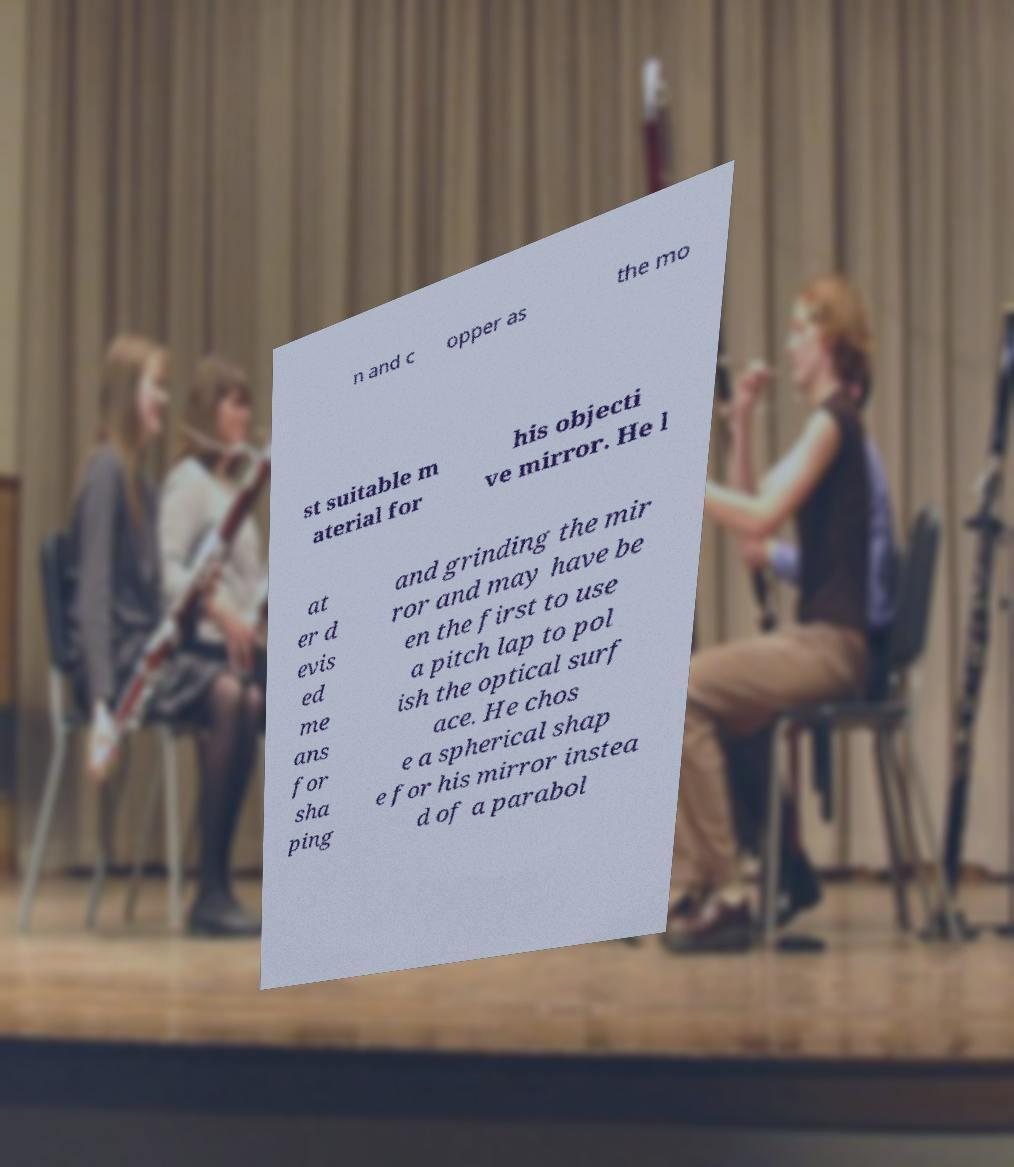What messages or text are displayed in this image? I need them in a readable, typed format. n and c opper as the mo st suitable m aterial for his objecti ve mirror. He l at er d evis ed me ans for sha ping and grinding the mir ror and may have be en the first to use a pitch lap to pol ish the optical surf ace. He chos e a spherical shap e for his mirror instea d of a parabol 